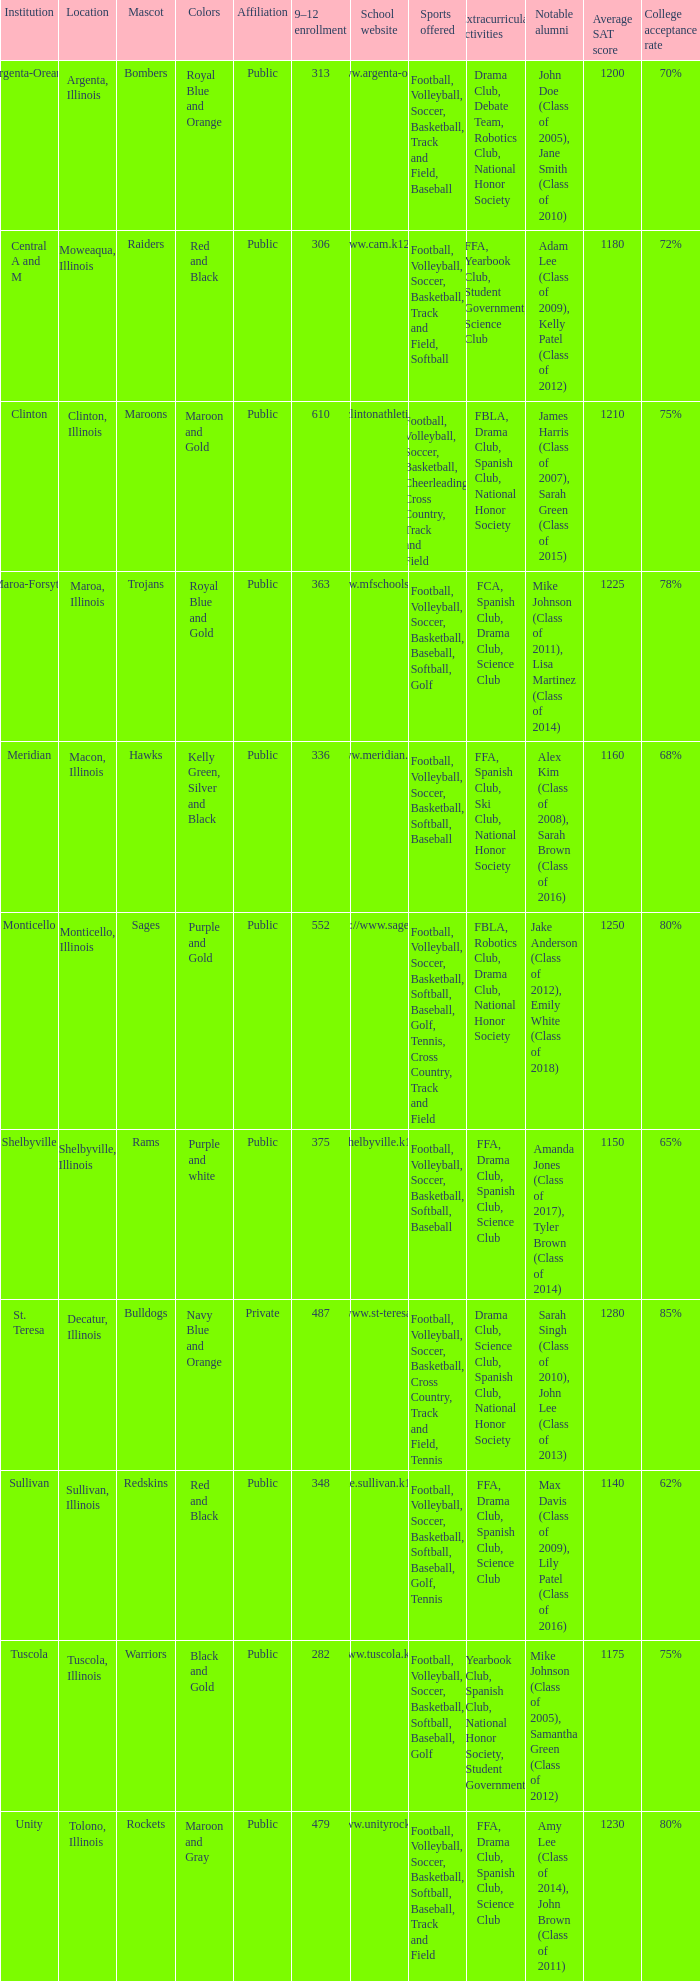What's the name of the city or town of the school that operates the http://www.mfschools.org/high/ website? Maroa-Forsyth. 